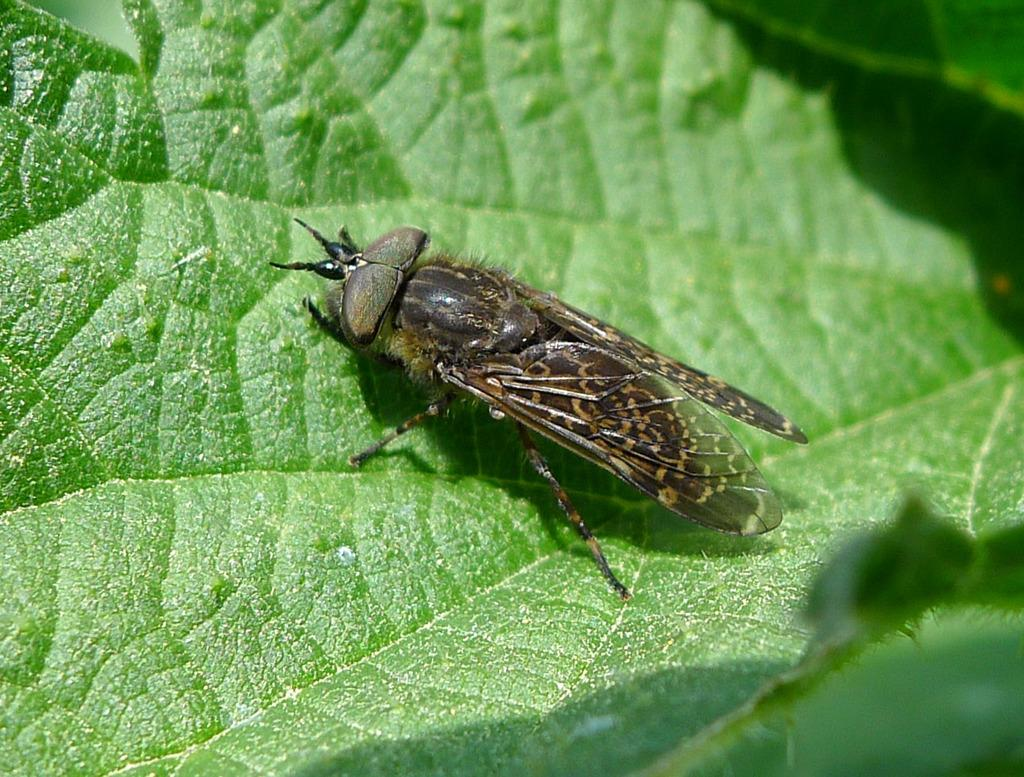What type of vegetation can be seen in the image? There are leaves in the image. Can you describe any living organisms present on the leaves? Yes, there is a leafhopper on a leaf in the image. What type of machine can be seen in the image? There is no machine present in the image; it features leaves and a leafhopper. What time of day is depicted in the image? The time of day cannot be determined from the image, as there are no specific indicators of time. 